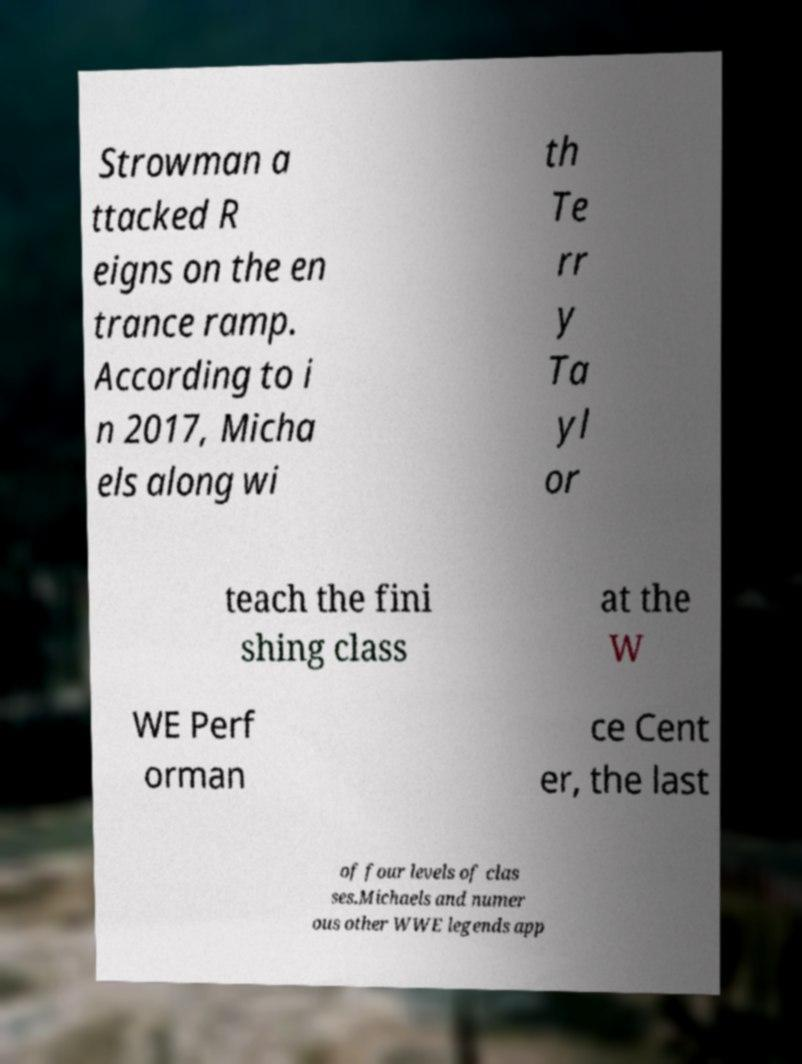There's text embedded in this image that I need extracted. Can you transcribe it verbatim? Strowman a ttacked R eigns on the en trance ramp. According to i n 2017, Micha els along wi th Te rr y Ta yl or teach the fini shing class at the W WE Perf orman ce Cent er, the last of four levels of clas ses.Michaels and numer ous other WWE legends app 